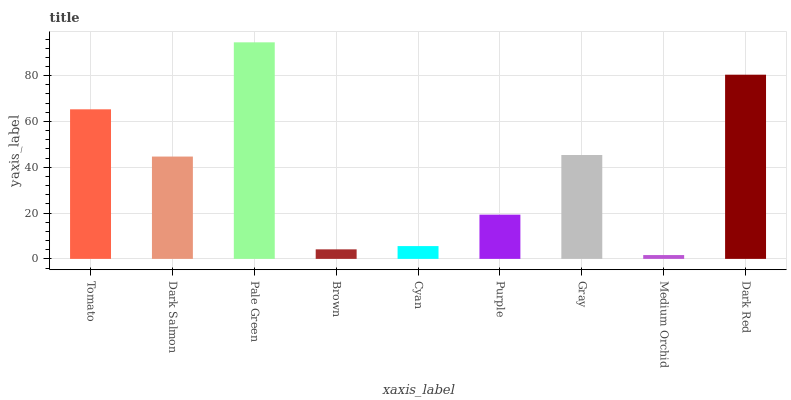Is Medium Orchid the minimum?
Answer yes or no. Yes. Is Pale Green the maximum?
Answer yes or no. Yes. Is Dark Salmon the minimum?
Answer yes or no. No. Is Dark Salmon the maximum?
Answer yes or no. No. Is Tomato greater than Dark Salmon?
Answer yes or no. Yes. Is Dark Salmon less than Tomato?
Answer yes or no. Yes. Is Dark Salmon greater than Tomato?
Answer yes or no. No. Is Tomato less than Dark Salmon?
Answer yes or no. No. Is Dark Salmon the high median?
Answer yes or no. Yes. Is Dark Salmon the low median?
Answer yes or no. Yes. Is Purple the high median?
Answer yes or no. No. Is Tomato the low median?
Answer yes or no. No. 